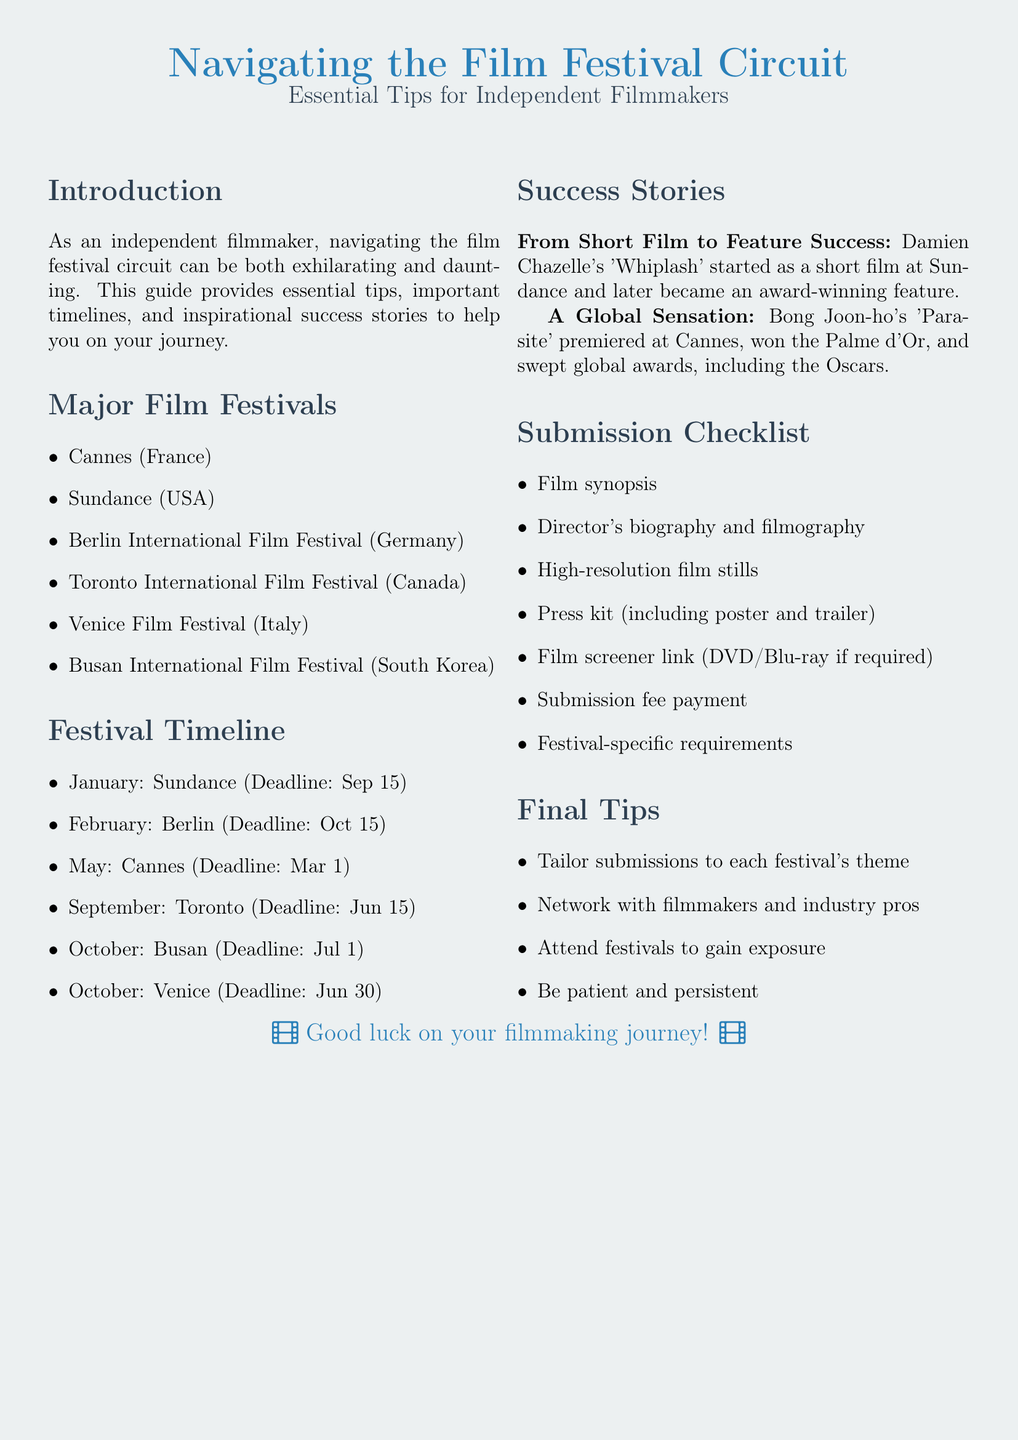What are the major film festivals listed? The document lists six major film festivals: Cannes, Sundance, Berlin International Film Festival, Toronto International Film Festival, Venice Film Festival, and Busan International Film Festival.
Answer: Cannes, Sundance, Berlin International Film Festival, Toronto International Film Festival, Venice Film Festival, Busan International Film Festival What is the deadline for Sundance submissions? The deadline for Sundance submissions is September 15, as stated in the festival timeline section.
Answer: September 15 Which filmmaker's success story is mentioned? The document mentions Damien Chazelle's success story regarding his film 'Whiplash.'
Answer: Damien Chazelle What should be included in the press kit? The checklist outlines that the press kit must include a poster and trailer among other items.
Answer: Poster and trailer How many festivals are mentioned in the timeline? The timeline section lists six festivals with their respective deadlines.
Answer: Six Which film won the Palme d'Or at Cannes? The document notes that Bong Joon-ho's 'Parasite' premiered at Cannes and won the Palme d'Or.
Answer: Parasite What is one of the final tips provided for filmmakers? The document gives several final tips, one of which is to network with filmmakers and industry pros.
Answer: Network with filmmakers and industry pros What is the background color of the document? The page color set in the document is film gray, which is noted in the code.
Answer: Film gray 